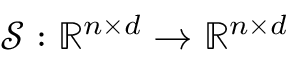Convert formula to latex. <formula><loc_0><loc_0><loc_500><loc_500>\mathcal { S } \colon \mathbb { R } ^ { n \times d } \rightarrow \mathbb { R } ^ { n \times d }</formula> 